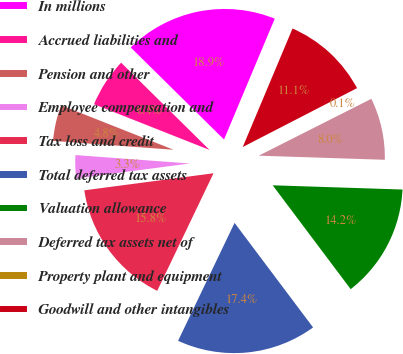<chart> <loc_0><loc_0><loc_500><loc_500><pie_chart><fcel>In millions<fcel>Accrued liabilities and<fcel>Pension and other<fcel>Employee compensation and<fcel>Tax loss and credit<fcel>Total deferred tax assets<fcel>Valuation allowance<fcel>Deferred tax assets net of<fcel>Property plant and equipment<fcel>Goodwill and other intangibles<nl><fcel>18.93%<fcel>6.4%<fcel>4.83%<fcel>3.26%<fcel>15.8%<fcel>17.36%<fcel>14.23%<fcel>7.96%<fcel>0.13%<fcel>11.1%<nl></chart> 